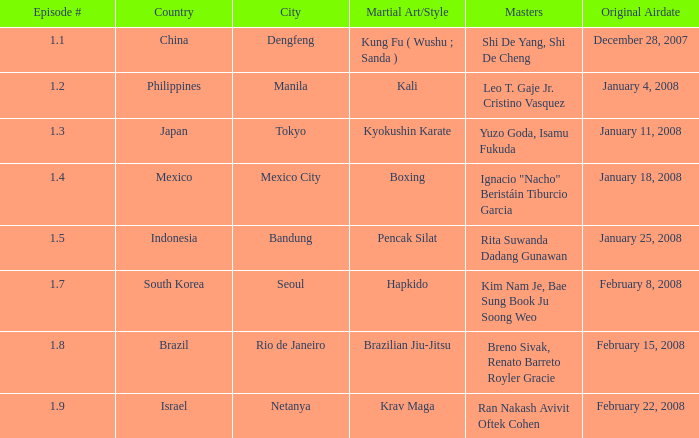Which masters fought in hapkido style? Kim Nam Je, Bae Sung Book Ju Soong Weo. 